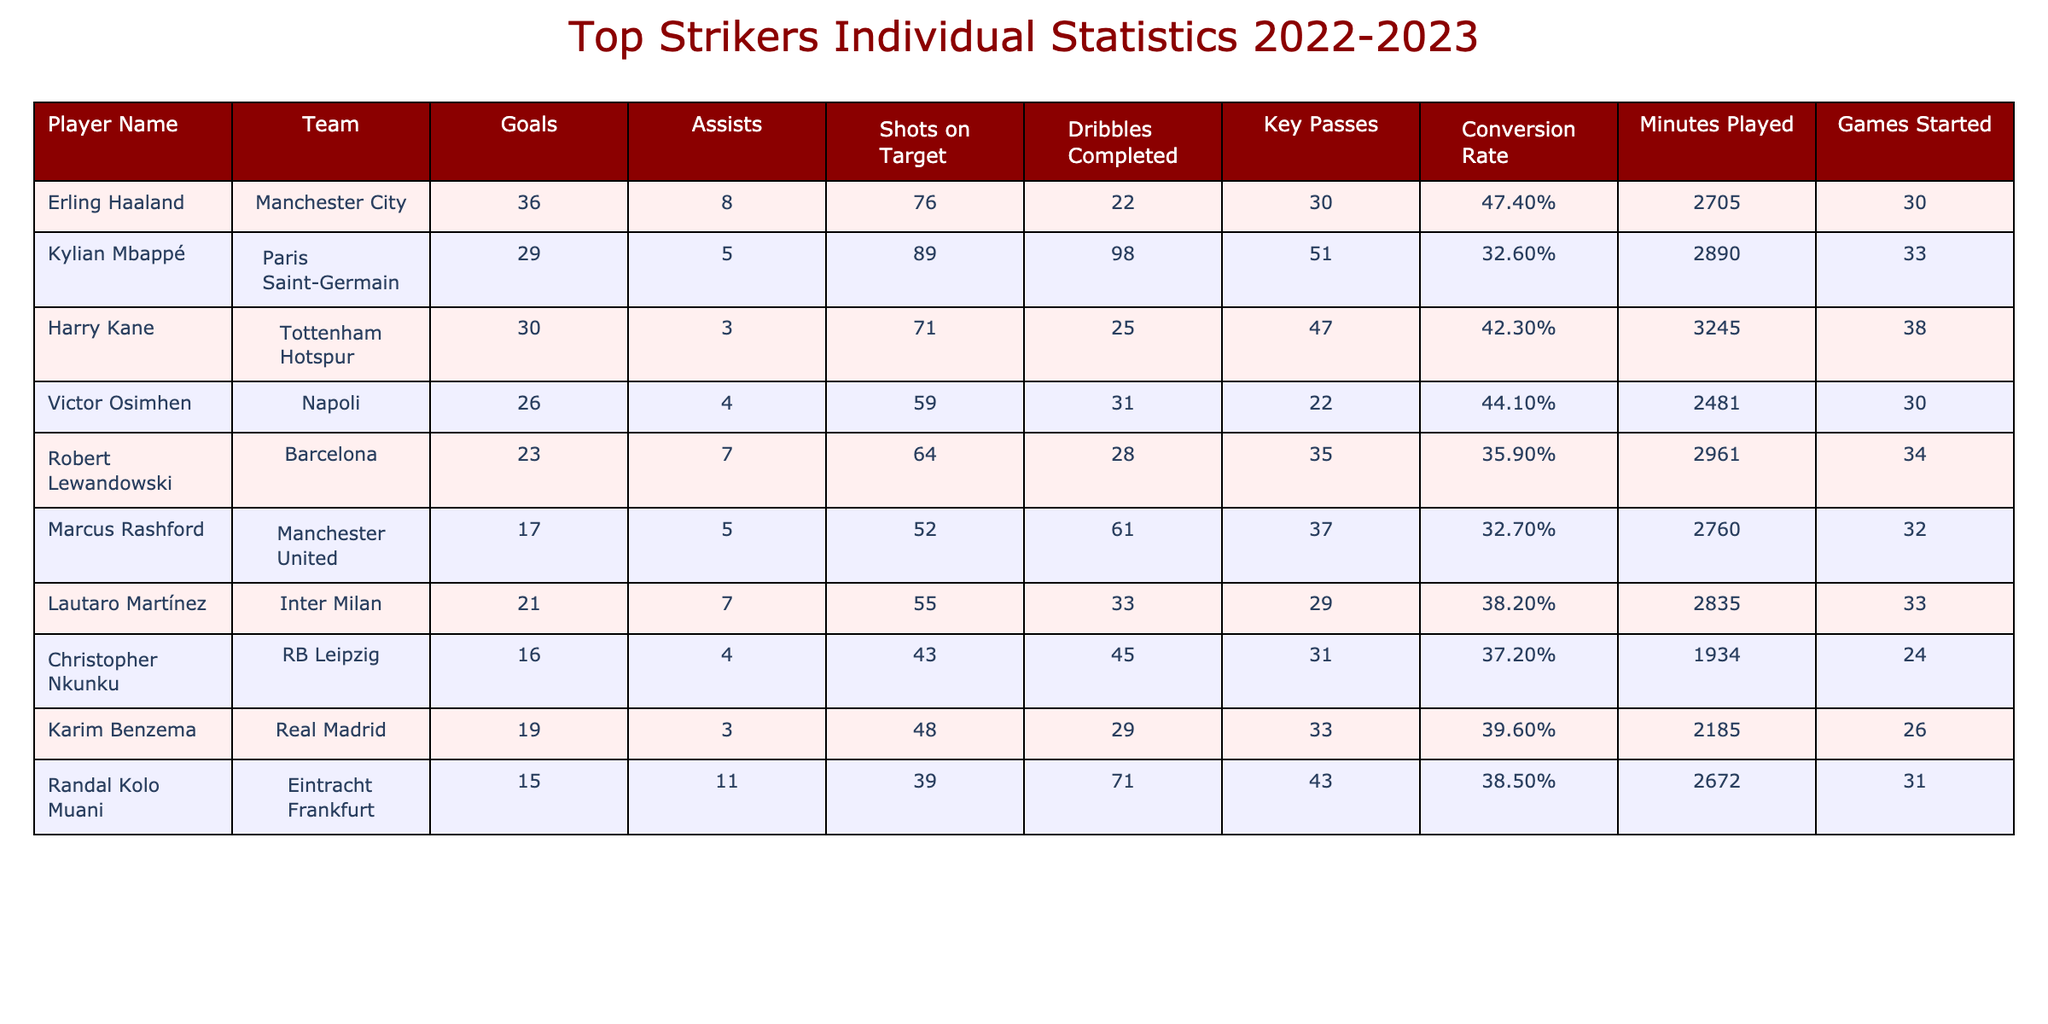What is the highest number of goals scored by a player? Looking at the "Goals" column, Erling Haaland has the highest value with 36 goals scored during the season.
Answer: 36 Which striker has the most assists? In the "Assists" column, Randal Kolo Muani has the highest number with 11 assists.
Answer: 11 What is the conversion rate of Kylian Mbappé? Kylian Mbappé's conversion rate is listed as 32.6%.
Answer: 32.6% How many minutes did Harry Kane play? The "Minutes Played" column shows that Harry Kane played for a total of 3,245 minutes.
Answer: 3245 What is the average number of goals scored by the players listed? Summing the goals (36 + 29 + 30 + 26 + 23 + 17 + 21 + 16 + 19 + 15) gives a total of  302 goals. Dividing by the number of players (10) results in an average of 30.2 goals.
Answer: 30.2 Which player had the highest shots on target? By referring to the "Shots on Target" column, Kylian Mbappé had the highest with 89 shots.
Answer: 89 Is it true that Robert Lewandowski had more assists than Victor Osimhen? Comparing the "Assists" column shows Lewandowski with 7 assists and Osimhen with 4 assists; therefore, the statement is true.
Answer: True What is the total number of games started by all players combined? By summing the "Games Started" values (30 + 33 + 38 + 30 + 34 + 32 + 33 + 24 + 26 + 31), the total is  319 games.
Answer: 319 Who has a higher dribble completion rate, Marcus Rashford or Lautaro Martínez? Marcus Rashford completed 61 dribbles, while Lautaro Martínez completed 33. Since Rashford completed more dribbles, he has a higher dribble completion rate compared to Martínez.
Answer: Marcus Rashford Calculate the difference in goals between the top scorer and the bottom scorer. The top scorer, Erling Haaland, scored 36 goals and the bottom scorer, Randal Kolo Muani, scored 15 goals. Thus, the difference is 36 - 15 = 21 goals.
Answer: 21 